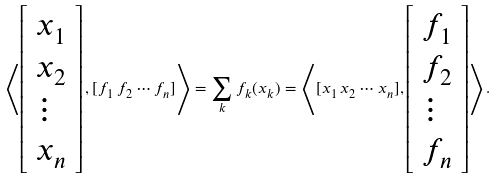Convert formula to latex. <formula><loc_0><loc_0><loc_500><loc_500>\left \langle \left [ \begin{array} { l } x _ { 1 } \\ x _ { 2 } \\ \vdots \\ x _ { n } \end{array} \right ] , [ f _ { 1 } \, f _ { 2 } \cdots f _ { n } ] \right \rangle = \sum _ { k } f _ { k } ( x _ { k } ) = \left \langle [ x _ { 1 } \, x _ { 2 } \cdots x _ { n } ] , \left [ \begin{array} { l } f _ { 1 } \\ f _ { 2 } \\ \vdots \\ f _ { n } \end{array} \right ] \right \rangle .</formula> 